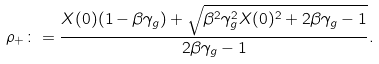<formula> <loc_0><loc_0><loc_500><loc_500>\rho _ { + } \colon = \frac { X ( 0 ) ( 1 - \beta \gamma _ { g } ) + \sqrt { \beta ^ { 2 } \gamma _ { g } ^ { 2 } X ( 0 ) ^ { 2 } + 2 \beta \gamma _ { g } - 1 } } { 2 \beta \gamma _ { g } - 1 } .</formula> 